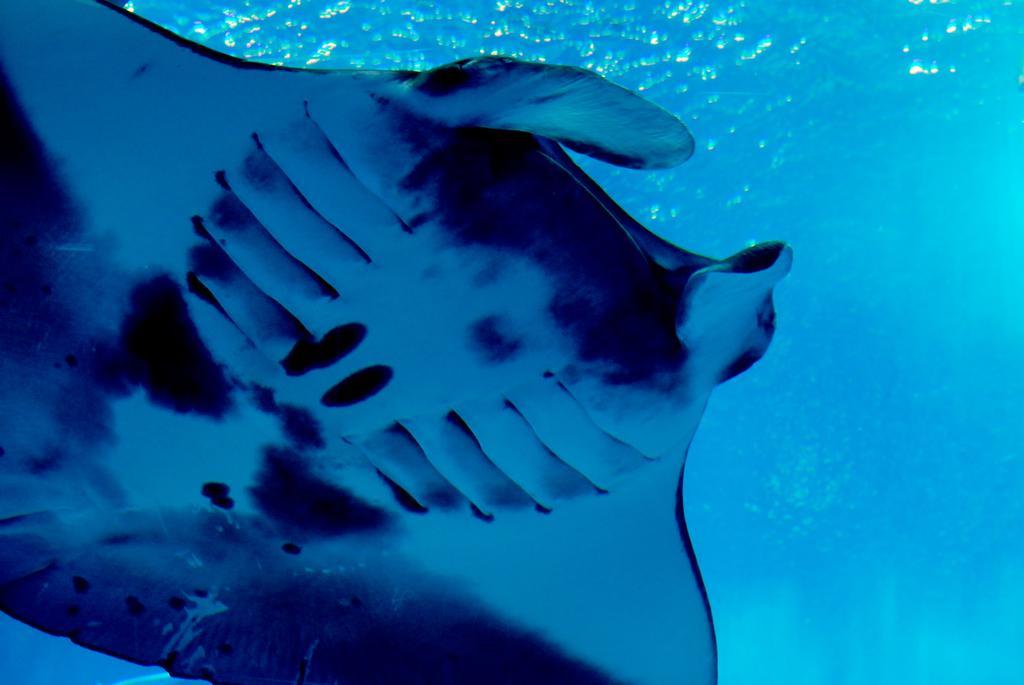Please provide a concise description of this image. Here we can see a manta ray in the water. 